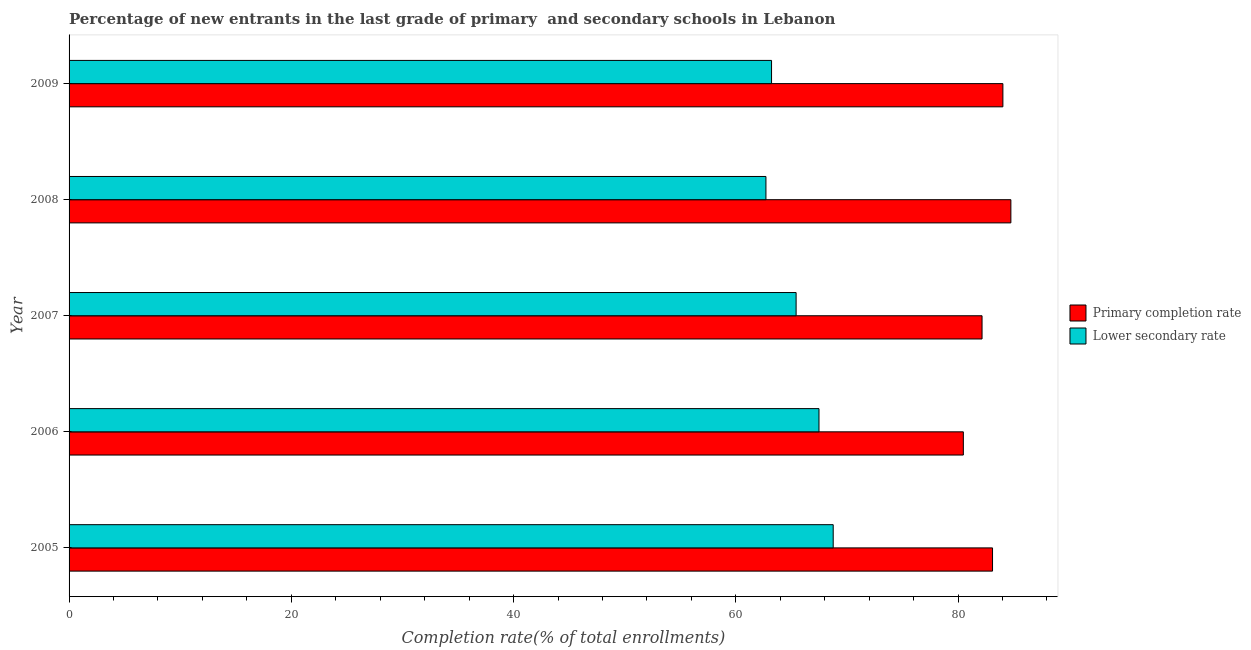How many different coloured bars are there?
Provide a short and direct response. 2. What is the completion rate in secondary schools in 2008?
Keep it short and to the point. 62.71. Across all years, what is the maximum completion rate in secondary schools?
Your answer should be compact. 68.76. Across all years, what is the minimum completion rate in primary schools?
Make the answer very short. 80.48. In which year was the completion rate in secondary schools maximum?
Ensure brevity in your answer.  2005. In which year was the completion rate in primary schools minimum?
Your answer should be very brief. 2006. What is the total completion rate in primary schools in the graph?
Your response must be concise. 414.53. What is the difference between the completion rate in primary schools in 2006 and that in 2007?
Your answer should be compact. -1.68. What is the difference between the completion rate in primary schools in 2008 and the completion rate in secondary schools in 2007?
Provide a succinct answer. 19.33. What is the average completion rate in secondary schools per year?
Ensure brevity in your answer.  65.52. In the year 2005, what is the difference between the completion rate in secondary schools and completion rate in primary schools?
Ensure brevity in your answer.  -14.34. What is the difference between the highest and the second highest completion rate in secondary schools?
Provide a short and direct response. 1.28. What is the difference between the highest and the lowest completion rate in primary schools?
Make the answer very short. 4.28. In how many years, is the completion rate in primary schools greater than the average completion rate in primary schools taken over all years?
Your response must be concise. 3. What does the 1st bar from the top in 2007 represents?
Ensure brevity in your answer.  Lower secondary rate. What does the 2nd bar from the bottom in 2005 represents?
Offer a terse response. Lower secondary rate. How many years are there in the graph?
Make the answer very short. 5. What is the difference between two consecutive major ticks on the X-axis?
Provide a succinct answer. 20. Are the values on the major ticks of X-axis written in scientific E-notation?
Your answer should be very brief. No. How many legend labels are there?
Provide a short and direct response. 2. How are the legend labels stacked?
Provide a short and direct response. Vertical. What is the title of the graph?
Give a very brief answer. Percentage of new entrants in the last grade of primary  and secondary schools in Lebanon. Does "Forest" appear as one of the legend labels in the graph?
Your answer should be very brief. No. What is the label or title of the X-axis?
Provide a succinct answer. Completion rate(% of total enrollments). What is the Completion rate(% of total enrollments) of Primary completion rate in 2005?
Offer a very short reply. 83.1. What is the Completion rate(% of total enrollments) of Lower secondary rate in 2005?
Ensure brevity in your answer.  68.76. What is the Completion rate(% of total enrollments) of Primary completion rate in 2006?
Give a very brief answer. 80.48. What is the Completion rate(% of total enrollments) of Lower secondary rate in 2006?
Offer a very short reply. 67.49. What is the Completion rate(% of total enrollments) in Primary completion rate in 2007?
Offer a very short reply. 82.16. What is the Completion rate(% of total enrollments) in Lower secondary rate in 2007?
Provide a succinct answer. 65.43. What is the Completion rate(% of total enrollments) in Primary completion rate in 2008?
Offer a very short reply. 84.75. What is the Completion rate(% of total enrollments) in Lower secondary rate in 2008?
Make the answer very short. 62.71. What is the Completion rate(% of total enrollments) in Primary completion rate in 2009?
Your answer should be compact. 84.03. What is the Completion rate(% of total enrollments) of Lower secondary rate in 2009?
Your answer should be compact. 63.22. Across all years, what is the maximum Completion rate(% of total enrollments) in Primary completion rate?
Your response must be concise. 84.75. Across all years, what is the maximum Completion rate(% of total enrollments) of Lower secondary rate?
Provide a short and direct response. 68.76. Across all years, what is the minimum Completion rate(% of total enrollments) in Primary completion rate?
Provide a succinct answer. 80.48. Across all years, what is the minimum Completion rate(% of total enrollments) in Lower secondary rate?
Your response must be concise. 62.71. What is the total Completion rate(% of total enrollments) of Primary completion rate in the graph?
Your response must be concise. 414.53. What is the total Completion rate(% of total enrollments) of Lower secondary rate in the graph?
Offer a terse response. 327.6. What is the difference between the Completion rate(% of total enrollments) in Primary completion rate in 2005 and that in 2006?
Your answer should be compact. 2.63. What is the difference between the Completion rate(% of total enrollments) in Lower secondary rate in 2005 and that in 2006?
Give a very brief answer. 1.28. What is the difference between the Completion rate(% of total enrollments) in Primary completion rate in 2005 and that in 2007?
Give a very brief answer. 0.94. What is the difference between the Completion rate(% of total enrollments) of Lower secondary rate in 2005 and that in 2007?
Provide a succinct answer. 3.34. What is the difference between the Completion rate(% of total enrollments) in Primary completion rate in 2005 and that in 2008?
Your answer should be very brief. -1.65. What is the difference between the Completion rate(% of total enrollments) of Lower secondary rate in 2005 and that in 2008?
Make the answer very short. 6.05. What is the difference between the Completion rate(% of total enrollments) in Primary completion rate in 2005 and that in 2009?
Give a very brief answer. -0.93. What is the difference between the Completion rate(% of total enrollments) in Lower secondary rate in 2005 and that in 2009?
Give a very brief answer. 5.55. What is the difference between the Completion rate(% of total enrollments) of Primary completion rate in 2006 and that in 2007?
Make the answer very short. -1.68. What is the difference between the Completion rate(% of total enrollments) in Lower secondary rate in 2006 and that in 2007?
Offer a very short reply. 2.06. What is the difference between the Completion rate(% of total enrollments) in Primary completion rate in 2006 and that in 2008?
Your response must be concise. -4.28. What is the difference between the Completion rate(% of total enrollments) in Lower secondary rate in 2006 and that in 2008?
Provide a short and direct response. 4.77. What is the difference between the Completion rate(% of total enrollments) in Primary completion rate in 2006 and that in 2009?
Offer a very short reply. -3.56. What is the difference between the Completion rate(% of total enrollments) in Lower secondary rate in 2006 and that in 2009?
Offer a terse response. 4.27. What is the difference between the Completion rate(% of total enrollments) in Primary completion rate in 2007 and that in 2008?
Ensure brevity in your answer.  -2.59. What is the difference between the Completion rate(% of total enrollments) of Lower secondary rate in 2007 and that in 2008?
Provide a succinct answer. 2.71. What is the difference between the Completion rate(% of total enrollments) in Primary completion rate in 2007 and that in 2009?
Your answer should be very brief. -1.87. What is the difference between the Completion rate(% of total enrollments) of Lower secondary rate in 2007 and that in 2009?
Ensure brevity in your answer.  2.21. What is the difference between the Completion rate(% of total enrollments) in Primary completion rate in 2008 and that in 2009?
Give a very brief answer. 0.72. What is the difference between the Completion rate(% of total enrollments) of Lower secondary rate in 2008 and that in 2009?
Ensure brevity in your answer.  -0.5. What is the difference between the Completion rate(% of total enrollments) in Primary completion rate in 2005 and the Completion rate(% of total enrollments) in Lower secondary rate in 2006?
Ensure brevity in your answer.  15.62. What is the difference between the Completion rate(% of total enrollments) of Primary completion rate in 2005 and the Completion rate(% of total enrollments) of Lower secondary rate in 2007?
Keep it short and to the point. 17.68. What is the difference between the Completion rate(% of total enrollments) of Primary completion rate in 2005 and the Completion rate(% of total enrollments) of Lower secondary rate in 2008?
Make the answer very short. 20.39. What is the difference between the Completion rate(% of total enrollments) in Primary completion rate in 2005 and the Completion rate(% of total enrollments) in Lower secondary rate in 2009?
Your response must be concise. 19.89. What is the difference between the Completion rate(% of total enrollments) in Primary completion rate in 2006 and the Completion rate(% of total enrollments) in Lower secondary rate in 2007?
Provide a succinct answer. 15.05. What is the difference between the Completion rate(% of total enrollments) of Primary completion rate in 2006 and the Completion rate(% of total enrollments) of Lower secondary rate in 2008?
Give a very brief answer. 17.76. What is the difference between the Completion rate(% of total enrollments) of Primary completion rate in 2006 and the Completion rate(% of total enrollments) of Lower secondary rate in 2009?
Ensure brevity in your answer.  17.26. What is the difference between the Completion rate(% of total enrollments) in Primary completion rate in 2007 and the Completion rate(% of total enrollments) in Lower secondary rate in 2008?
Offer a very short reply. 19.45. What is the difference between the Completion rate(% of total enrollments) in Primary completion rate in 2007 and the Completion rate(% of total enrollments) in Lower secondary rate in 2009?
Offer a terse response. 18.94. What is the difference between the Completion rate(% of total enrollments) of Primary completion rate in 2008 and the Completion rate(% of total enrollments) of Lower secondary rate in 2009?
Provide a succinct answer. 21.54. What is the average Completion rate(% of total enrollments) of Primary completion rate per year?
Your answer should be compact. 82.91. What is the average Completion rate(% of total enrollments) in Lower secondary rate per year?
Your answer should be very brief. 65.52. In the year 2005, what is the difference between the Completion rate(% of total enrollments) of Primary completion rate and Completion rate(% of total enrollments) of Lower secondary rate?
Make the answer very short. 14.34. In the year 2006, what is the difference between the Completion rate(% of total enrollments) in Primary completion rate and Completion rate(% of total enrollments) in Lower secondary rate?
Provide a short and direct response. 12.99. In the year 2007, what is the difference between the Completion rate(% of total enrollments) in Primary completion rate and Completion rate(% of total enrollments) in Lower secondary rate?
Your response must be concise. 16.73. In the year 2008, what is the difference between the Completion rate(% of total enrollments) in Primary completion rate and Completion rate(% of total enrollments) in Lower secondary rate?
Keep it short and to the point. 22.04. In the year 2009, what is the difference between the Completion rate(% of total enrollments) of Primary completion rate and Completion rate(% of total enrollments) of Lower secondary rate?
Provide a succinct answer. 20.82. What is the ratio of the Completion rate(% of total enrollments) in Primary completion rate in 2005 to that in 2006?
Offer a terse response. 1.03. What is the ratio of the Completion rate(% of total enrollments) in Primary completion rate in 2005 to that in 2007?
Keep it short and to the point. 1.01. What is the ratio of the Completion rate(% of total enrollments) in Lower secondary rate in 2005 to that in 2007?
Give a very brief answer. 1.05. What is the ratio of the Completion rate(% of total enrollments) of Primary completion rate in 2005 to that in 2008?
Offer a terse response. 0.98. What is the ratio of the Completion rate(% of total enrollments) in Lower secondary rate in 2005 to that in 2008?
Your answer should be compact. 1.1. What is the ratio of the Completion rate(% of total enrollments) in Primary completion rate in 2005 to that in 2009?
Provide a short and direct response. 0.99. What is the ratio of the Completion rate(% of total enrollments) in Lower secondary rate in 2005 to that in 2009?
Ensure brevity in your answer.  1.09. What is the ratio of the Completion rate(% of total enrollments) of Primary completion rate in 2006 to that in 2007?
Your answer should be compact. 0.98. What is the ratio of the Completion rate(% of total enrollments) of Lower secondary rate in 2006 to that in 2007?
Your answer should be very brief. 1.03. What is the ratio of the Completion rate(% of total enrollments) of Primary completion rate in 2006 to that in 2008?
Give a very brief answer. 0.95. What is the ratio of the Completion rate(% of total enrollments) in Lower secondary rate in 2006 to that in 2008?
Your answer should be very brief. 1.08. What is the ratio of the Completion rate(% of total enrollments) in Primary completion rate in 2006 to that in 2009?
Provide a succinct answer. 0.96. What is the ratio of the Completion rate(% of total enrollments) of Lower secondary rate in 2006 to that in 2009?
Your response must be concise. 1.07. What is the ratio of the Completion rate(% of total enrollments) in Primary completion rate in 2007 to that in 2008?
Give a very brief answer. 0.97. What is the ratio of the Completion rate(% of total enrollments) of Lower secondary rate in 2007 to that in 2008?
Make the answer very short. 1.04. What is the ratio of the Completion rate(% of total enrollments) of Primary completion rate in 2007 to that in 2009?
Ensure brevity in your answer.  0.98. What is the ratio of the Completion rate(% of total enrollments) of Lower secondary rate in 2007 to that in 2009?
Keep it short and to the point. 1.03. What is the ratio of the Completion rate(% of total enrollments) of Primary completion rate in 2008 to that in 2009?
Your answer should be very brief. 1.01. What is the difference between the highest and the second highest Completion rate(% of total enrollments) of Primary completion rate?
Offer a very short reply. 0.72. What is the difference between the highest and the second highest Completion rate(% of total enrollments) of Lower secondary rate?
Offer a very short reply. 1.28. What is the difference between the highest and the lowest Completion rate(% of total enrollments) of Primary completion rate?
Give a very brief answer. 4.28. What is the difference between the highest and the lowest Completion rate(% of total enrollments) of Lower secondary rate?
Provide a short and direct response. 6.05. 